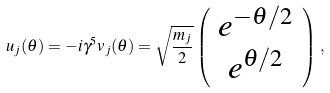Convert formula to latex. <formula><loc_0><loc_0><loc_500><loc_500>u _ { j } ( \theta ) = - i \gamma ^ { 5 } v _ { j } ( \theta ) = \sqrt { \frac { m _ { j } } { 2 } } \left ( \begin{array} { c } e ^ { - \theta / 2 } \\ e ^ { \theta / 2 } \end{array} \right ) \, ,</formula> 